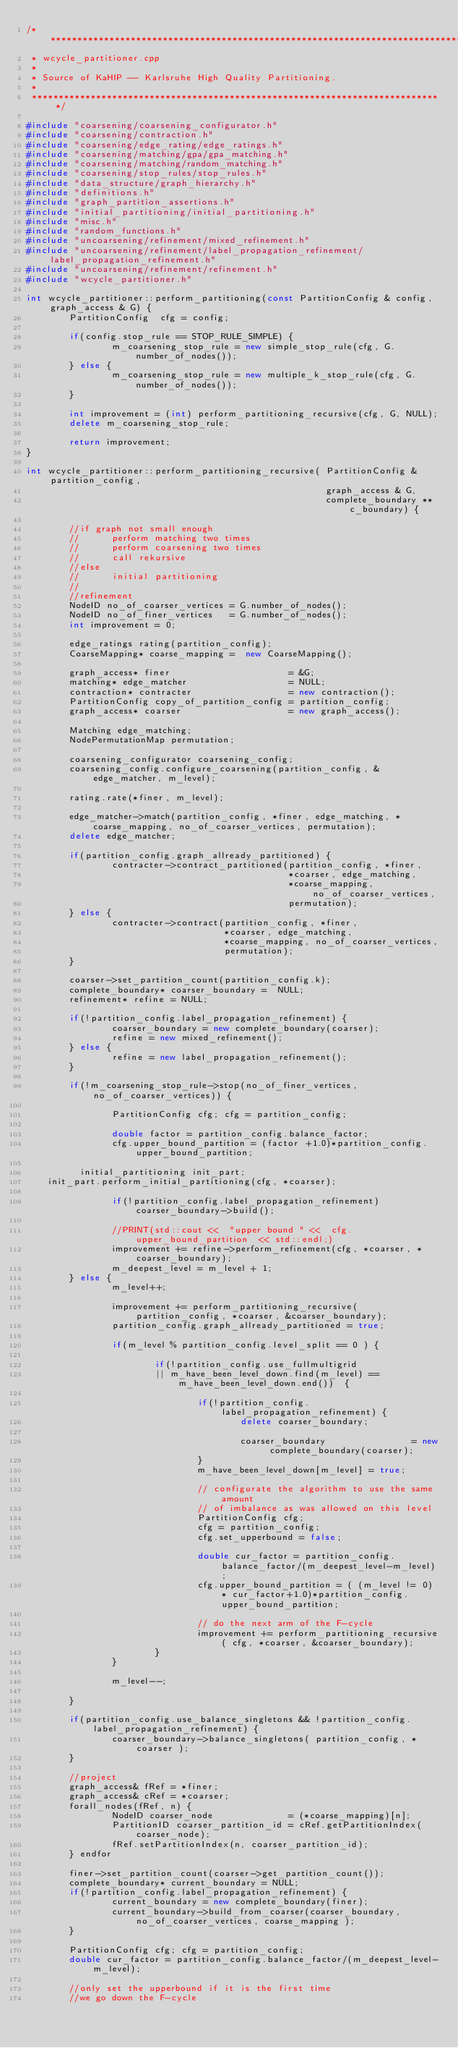<code> <loc_0><loc_0><loc_500><loc_500><_C++_>/******************************************************************************
 * wcycle_partitioner.cpp 
 *
 * Source of KaHIP -- Karlsruhe High Quality Partitioning.
 *
 *****************************************************************************/

#include "coarsening/coarsening_configurator.h"
#include "coarsening/contraction.h"
#include "coarsening/edge_rating/edge_ratings.h"
#include "coarsening/matching/gpa/gpa_matching.h"
#include "coarsening/matching/random_matching.h"
#include "coarsening/stop_rules/stop_rules.h"
#include "data_structure/graph_hierarchy.h"
#include "definitions.h"
#include "graph_partition_assertions.h"
#include "initial_partitioning/initial_partitioning.h"
#include "misc.h"
#include "random_functions.h"
#include "uncoarsening/refinement/mixed_refinement.h"
#include "uncoarsening/refinement/label_propagation_refinement/label_propagation_refinement.h"
#include "uncoarsening/refinement/refinement.h"
#include "wcycle_partitioner.h"

int wcycle_partitioner::perform_partitioning(const PartitionConfig & config, graph_access & G) {
        PartitionConfig  cfg = config; 

        if(config.stop_rule == STOP_RULE_SIMPLE) {
                m_coarsening_stop_rule = new simple_stop_rule(cfg, G.number_of_nodes());
        } else {
                m_coarsening_stop_rule = new multiple_k_stop_rule(cfg, G.number_of_nodes());
        }

        int improvement = (int) perform_partitioning_recursive(cfg, G, NULL); 
        delete m_coarsening_stop_rule;

        return improvement;
}

int wcycle_partitioner::perform_partitioning_recursive( PartitionConfig & partition_config, 
                                                        graph_access & G, 
                                                        complete_boundary ** c_boundary) {

        //if graph not small enough
        //      perform matching two times
        //      perform coarsening two times
        //      call rekursive
        //else 
        //      initial partitioning
        //
        //refinement
        NodeID no_of_coarser_vertices = G.number_of_nodes();
        NodeID no_of_finer_vertices   = G.number_of_nodes();
        int improvement = 0;

        edge_ratings rating(partition_config);
        CoarseMapping* coarse_mapping =  new CoarseMapping();

        graph_access* finer                      = &G;
        matching* edge_matcher                   = NULL;
        contraction* contracter                  = new contraction();
        PartitionConfig copy_of_partition_config = partition_config;
        graph_access* coarser                    = new graph_access();

        Matching edge_matching;
        NodePermutationMap permutation;

        coarsening_configurator coarsening_config;
        coarsening_config.configure_coarsening(partition_config, &edge_matcher, m_level);
        
        rating.rate(*finer, m_level);

        edge_matcher->match(partition_config, *finer, edge_matching, *coarse_mapping, no_of_coarser_vertices, permutation);
        delete edge_matcher; 

        if(partition_config.graph_allready_partitioned) {
                contracter->contract_partitioned(partition_config, *finer, 
                                                 *coarser, edge_matching, 
                                                 *coarse_mapping, no_of_coarser_vertices, 
                                                 permutation);
        } else {
                contracter->contract(partition_config, *finer, 
                                     *coarser, edge_matching, 
                                     *coarse_mapping, no_of_coarser_vertices, 
                                     permutation);
        }

        coarser->set_partition_count(partition_config.k);
        complete_boundary* coarser_boundary =  NULL;
        refinement* refine = NULL;

        if(!partition_config.label_propagation_refinement) {
                coarser_boundary = new complete_boundary(coarser);
                refine = new mixed_refinement();
        } else {
                refine = new label_propagation_refinement();
        }

        if(!m_coarsening_stop_rule->stop(no_of_finer_vertices, no_of_coarser_vertices)) {

                PartitionConfig cfg; cfg = partition_config;

                double factor = partition_config.balance_factor;
                cfg.upper_bound_partition = (factor +1.0)*partition_config.upper_bound_partition;

	        initial_partitioning init_part;
		init_part.perform_initial_partitioning(cfg, *coarser);

                if(!partition_config.label_propagation_refinement) coarser_boundary->build();

                //PRINT(std::cout <<  "upper bound " <<  cfg.upper_bound_partition  << std::endl;)
                improvement += refine->perform_refinement(cfg, *coarser, *coarser_boundary);
                m_deepest_level = m_level + 1;
        } else {
                m_level++;

                improvement += perform_partitioning_recursive( partition_config, *coarser, &coarser_boundary); 
                partition_config.graph_allready_partitioned = true;

                if(m_level % partition_config.level_split == 0 ) {

                        if(!partition_config.use_fullmultigrid 
                        || m_have_been_level_down.find(m_level) == m_have_been_level_down.end())  { 

                                if(!partition_config.label_propagation_refinement) {
                                        delete coarser_boundary;

                                        coarser_boundary                = new complete_boundary(coarser);
                                }
                                m_have_been_level_down[m_level] = true;

                                // configurate the algorithm to use the same amount
                                // of imbalance as was allowed on this level 
                                PartitionConfig cfg;
                                cfg = partition_config;
                                cfg.set_upperbound = false;

                                double cur_factor = partition_config.balance_factor/(m_deepest_level-m_level);
                                cfg.upper_bound_partition = ( (m_level != 0) * cur_factor+1.0)*partition_config.upper_bound_partition;

                                // do the next arm of the F-cycle
                                improvement += perform_partitioning_recursive( cfg, *coarser, &coarser_boundary); 
                        }
                }

                m_level--;

        }

        if(partition_config.use_balance_singletons && !partition_config.label_propagation_refinement) {
                coarser_boundary->balance_singletons( partition_config, *coarser );
        }
        
        //project
        graph_access& fRef = *finer;
        graph_access& cRef = *coarser;
        forall_nodes(fRef, n) {
                NodeID coarser_node              = (*coarse_mapping)[n];
                PartitionID coarser_partition_id = cRef.getPartitionIndex(coarser_node);
                fRef.setPartitionIndex(n, coarser_partition_id);
        } endfor

        finer->set_partition_count(coarser->get_partition_count());
        complete_boundary* current_boundary = NULL;
        if(!partition_config.label_propagation_refinement) {
                current_boundary = new complete_boundary(finer);
                current_boundary->build_from_coarser(coarser_boundary, no_of_coarser_vertices, coarse_mapping ); 
        }

        PartitionConfig cfg; cfg = partition_config;
        double cur_factor = partition_config.balance_factor/(m_deepest_level-m_level);

        //only set the upperbound if it is the first time 
        //we go down the F-cycle</code> 